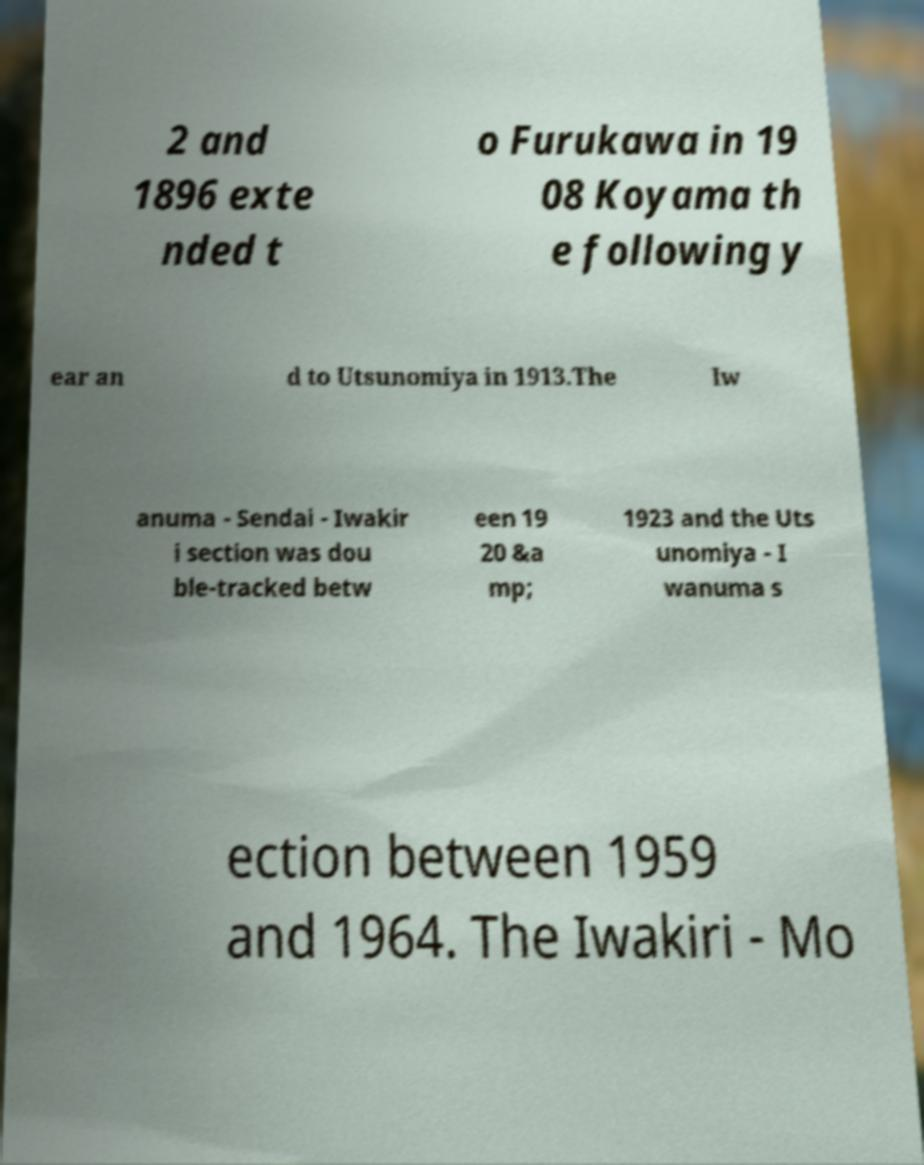Could you assist in decoding the text presented in this image and type it out clearly? 2 and 1896 exte nded t o Furukawa in 19 08 Koyama th e following y ear an d to Utsunomiya in 1913.The Iw anuma - Sendai - Iwakir i section was dou ble-tracked betw een 19 20 &a mp; 1923 and the Uts unomiya - I wanuma s ection between 1959 and 1964. The Iwakiri - Mo 